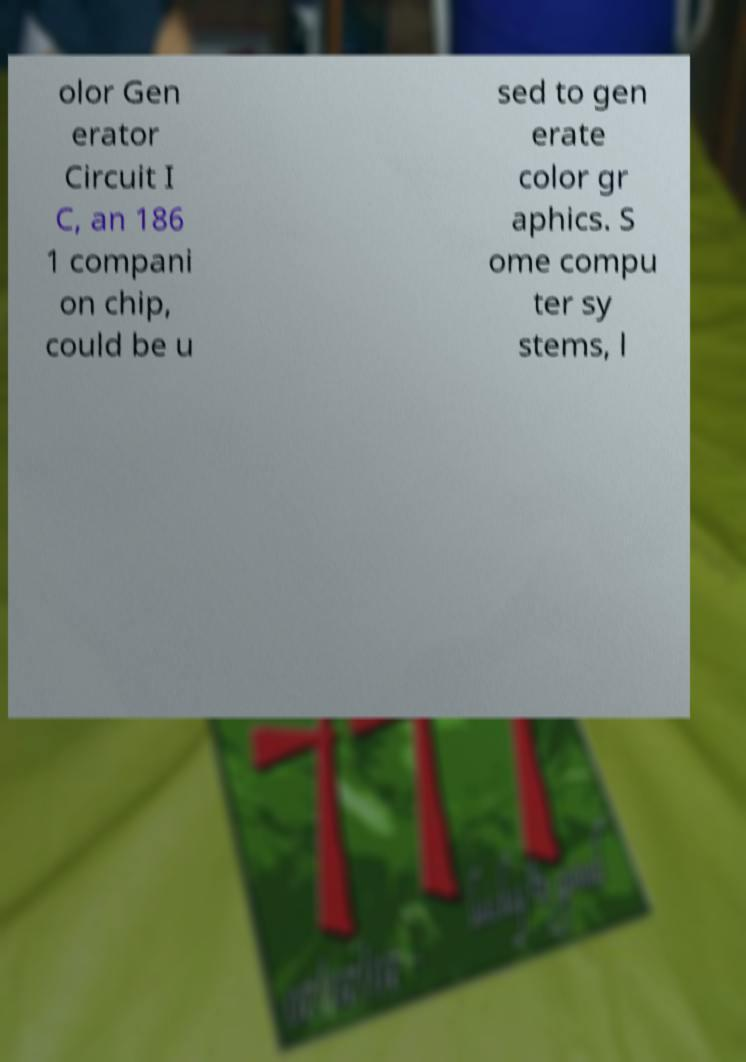There's text embedded in this image that I need extracted. Can you transcribe it verbatim? olor Gen erator Circuit I C, an 186 1 compani on chip, could be u sed to gen erate color gr aphics. S ome compu ter sy stems, l 